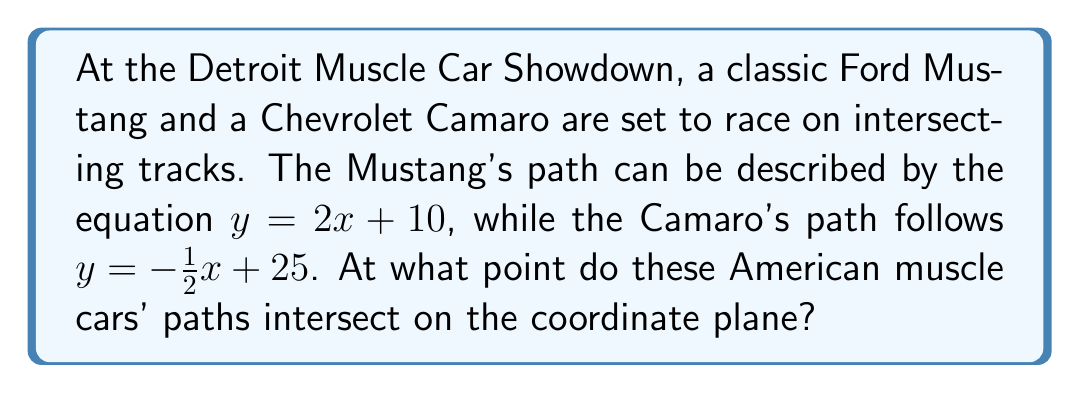Can you solve this math problem? To find the intersection point of the two cars' paths, we need to solve the system of equations:

$$\begin{cases}
y = 2x + 10 \quad \text{(Mustang's path)} \\
y = -\frac{1}{2}x + 25 \quad \text{(Camaro's path)}
\end{cases}$$

Since both equations are equal to $y$, we can set them equal to each other:

$$2x + 10 = -\frac{1}{2}x + 25$$

Now, let's solve for $x$:

1) First, add $\frac{1}{2}x$ to both sides:
   $$2x + \frac{1}{2}x + 10 = 25$$
   $$\frac{5}{2}x + 10 = 25$$

2) Subtract 10 from both sides:
   $$\frac{5}{2}x = 15$$

3) Multiply both sides by $\frac{2}{5}$:
   $$x = 15 \cdot \frac{2}{5} = 6$$

Now that we have the $x$-coordinate, we can find the $y$-coordinate by plugging $x = 6$ into either of the original equations. Let's use the Mustang's equation:

$$y = 2(6) + 10 = 12 + 10 = 22$$

Therefore, the intersection point is $(6, 22)$.

[asy]
unitsize(1cm);
defaultpen(fontsize(10pt));

// Draw axes
draw((-1,0)--(8,0), arrow=Arrow(TeXHead));
draw((0,-1)--(0,25), arrow=Arrow(TeXHead));

// Label axes
label("$x$", (8,0), E);
label("$y$", (0,25), N);

// Draw Mustang's path
draw((0,10)--(7,24), blue, Arrows(TeXHead));
label("Mustang", (7,24), NE, blue);

// Draw Camaro's path
draw((0,25)--(8,21), red, Arrows(TeXHead));
label("Camaro", (0,25), NW, red);

// Mark intersection point
dot((6,22), linewidth(4pt));
label("(6, 22)", (6,22), SE);
[/asy]
Answer: The paths of the Mustang and Camaro intersect at the point $(6, 22)$. 